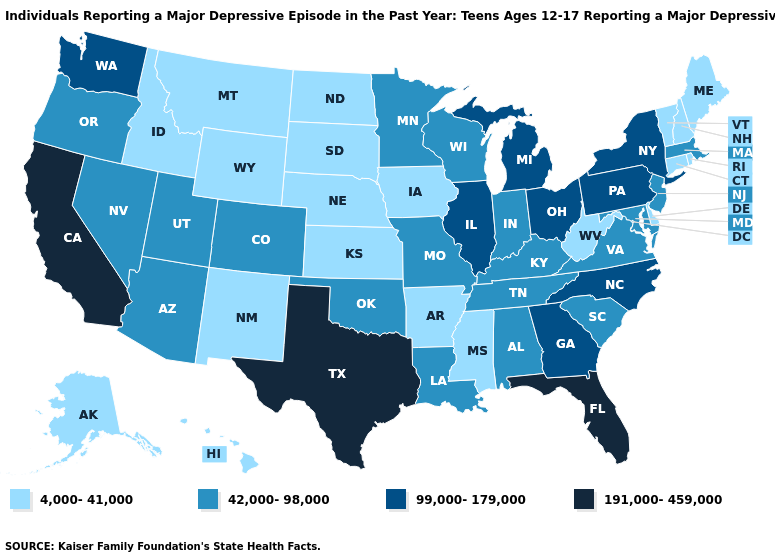Does the map have missing data?
Be succinct. No. What is the value of Mississippi?
Write a very short answer. 4,000-41,000. What is the value of Colorado?
Keep it brief. 42,000-98,000. What is the value of New Mexico?
Answer briefly. 4,000-41,000. What is the lowest value in states that border New York?
Keep it brief. 4,000-41,000. What is the value of Colorado?
Quick response, please. 42,000-98,000. Which states hav the highest value in the Northeast?
Write a very short answer. New York, Pennsylvania. What is the highest value in the USA?
Give a very brief answer. 191,000-459,000. Does South Dakota have the lowest value in the MidWest?
Answer briefly. Yes. What is the lowest value in the USA?
Concise answer only. 4,000-41,000. Which states have the lowest value in the USA?
Concise answer only. Alaska, Arkansas, Connecticut, Delaware, Hawaii, Idaho, Iowa, Kansas, Maine, Mississippi, Montana, Nebraska, New Hampshire, New Mexico, North Dakota, Rhode Island, South Dakota, Vermont, West Virginia, Wyoming. Does the map have missing data?
Be succinct. No. What is the value of South Carolina?
Be succinct. 42,000-98,000. Name the states that have a value in the range 99,000-179,000?
Quick response, please. Georgia, Illinois, Michigan, New York, North Carolina, Ohio, Pennsylvania, Washington. Which states have the highest value in the USA?
Short answer required. California, Florida, Texas. 